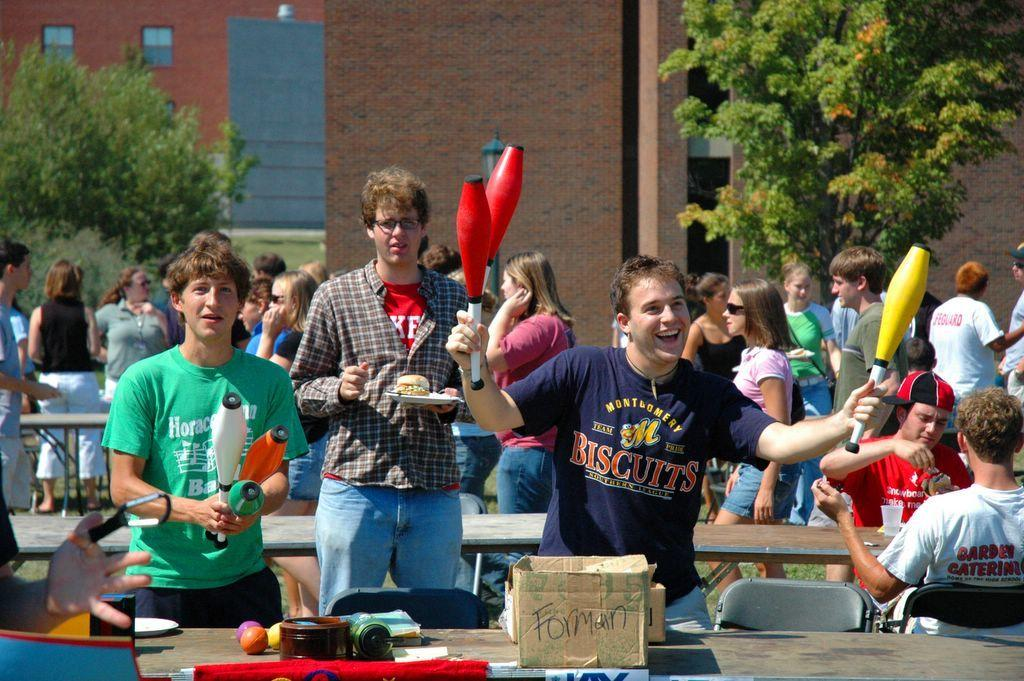<image>
Write a terse but informative summary of the picture. A man waving juggling clubs is wearing a t-shirt with biscuits written across the front. 